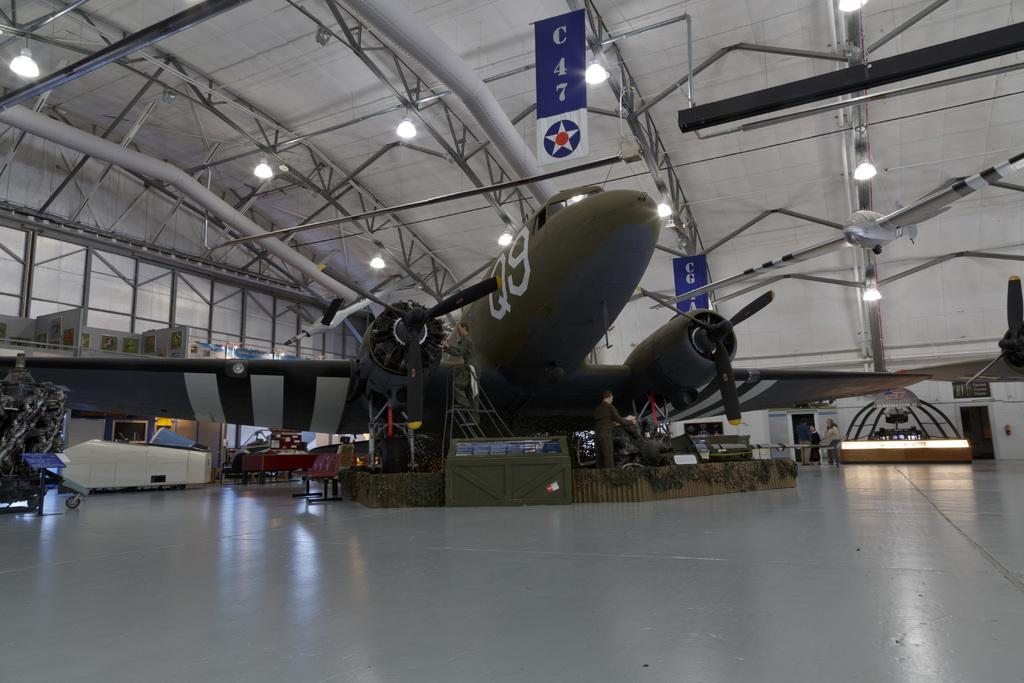<image>
Offer a succinct explanation of the picture presented. A green plane with the letter Q and number 9 on the front 